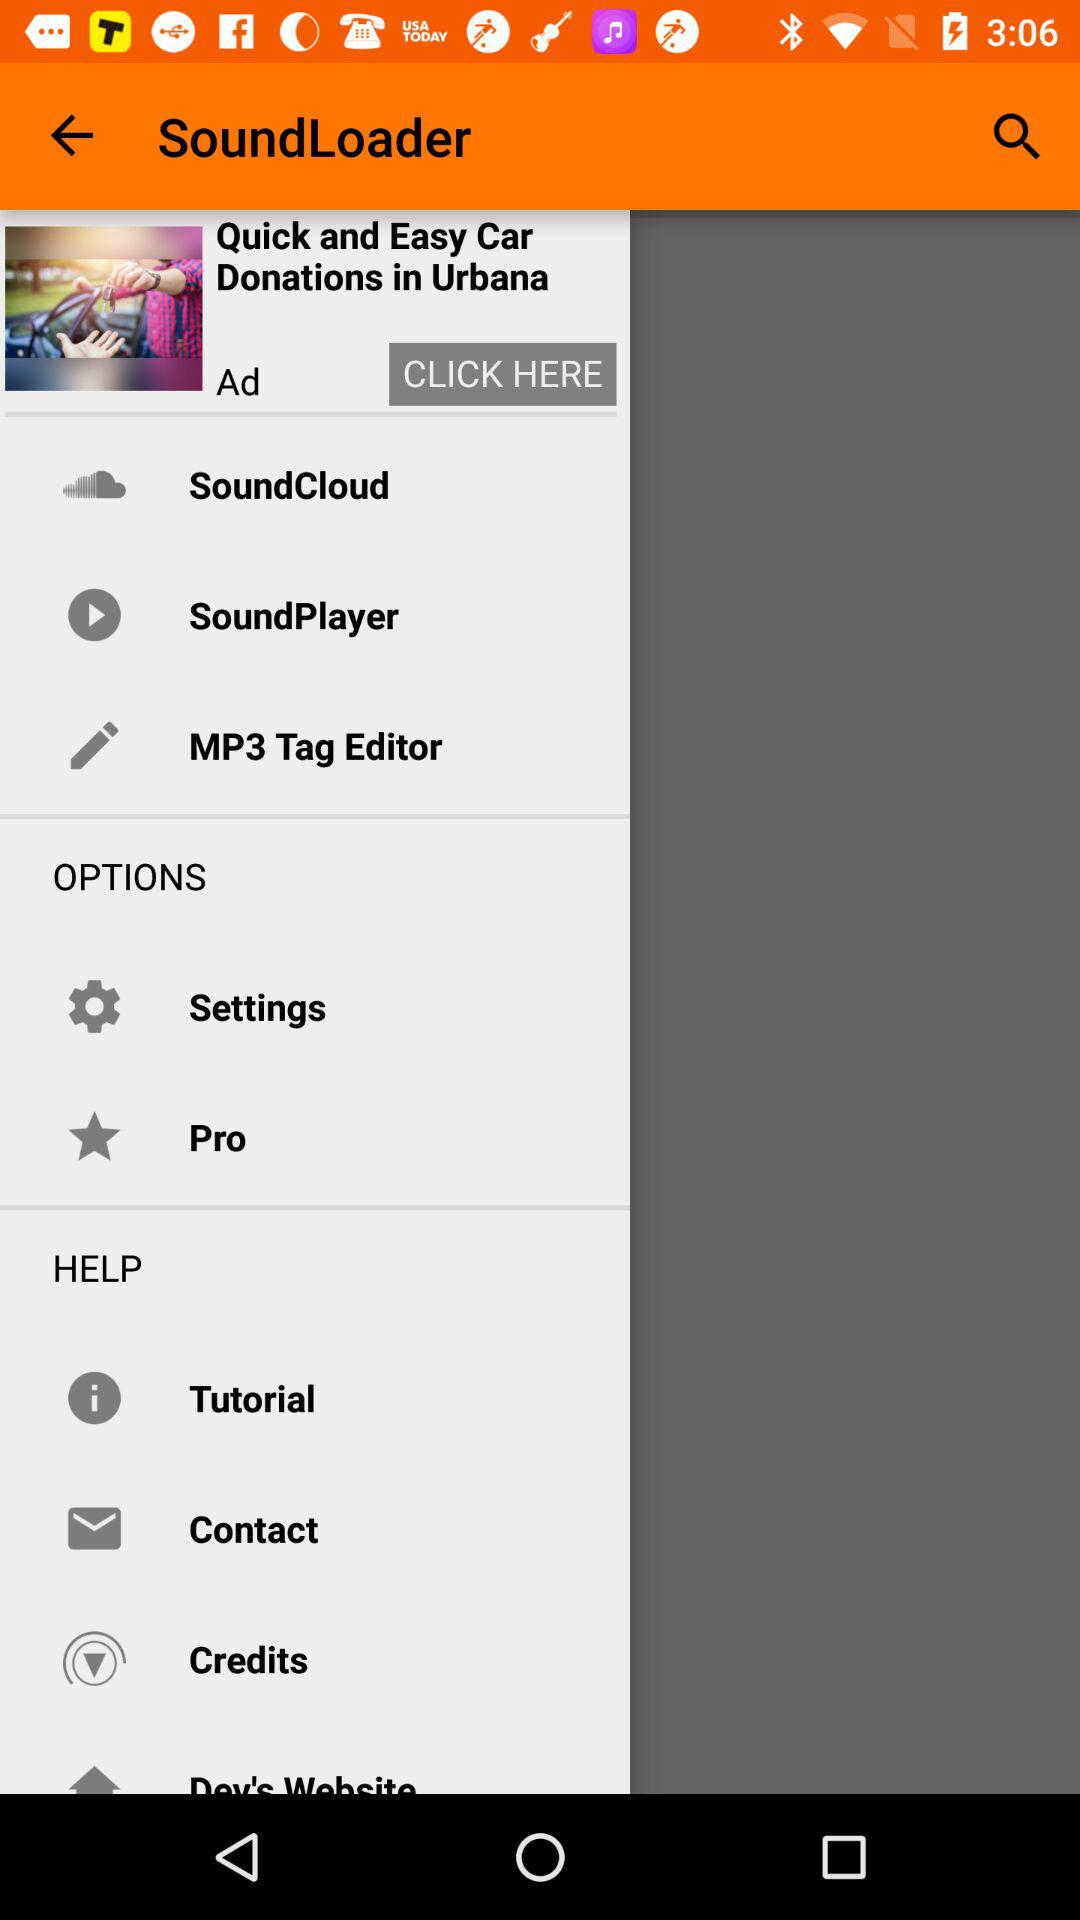What is the name of the application? The name of the application is "SoundLoader". 